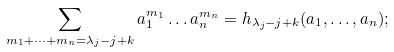<formula> <loc_0><loc_0><loc_500><loc_500>\sum _ { m _ { 1 } + \dots + m _ { n } = \lambda _ { j } - j + k } a _ { 1 } ^ { m _ { 1 } } \dots a _ { n } ^ { m _ { n } } = h _ { \lambda _ { j } - j + k } ( a _ { 1 } , \dots , a _ { n } ) ;</formula> 